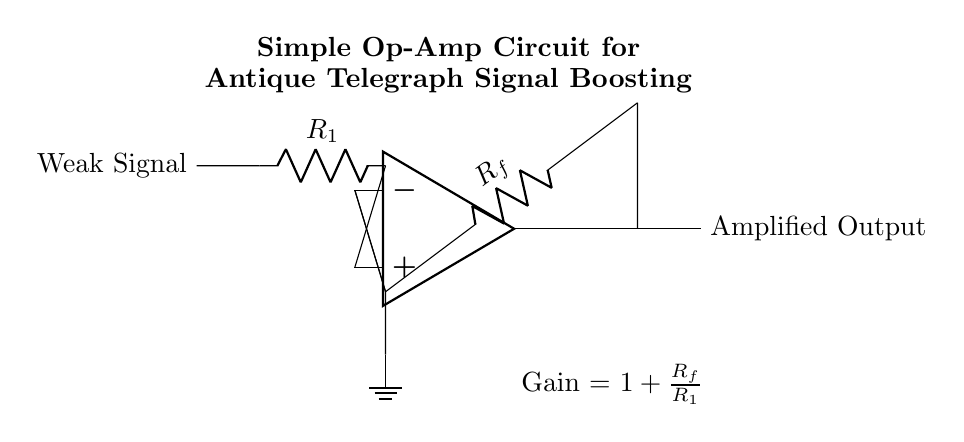What type of amplifier is shown in the circuit? The circuit represents an operational amplifier (op-amp) configuration designed for signal amplification. The label "op amp" in the circuit diagram indicates the specific component used for amplification.
Answer: operational amplifier What is the purpose of this circuit? The circuit's primary purpose is to boost weak signals, specifically for antique telegraph equipment. It's indicated in the label at the top of the diagram, showing it’s intended for signal boosting in telegraph applications.
Answer: boost weak signals What does Rf represent in the schematic? Rf, labeled in the diagram, represents the feedback resistor used in the op-amp configuration. Its placement in the feedback loop is essential for determining the gain of the amplifier.
Answer: feedback resistor How is the gain of the amplifier calculated? The gain of the amplifier is given by the formula "1 + Rf/R1." This is indicated in the circuit below the op-amp, showing how the feedback resistor and the input resistor R1 affect the overall gain.
Answer: 1 + Rf/R1 Which component is responsible for the input weak signal? The weak signal enters the circuit through the resistor R1, connected to the non-inverting input of the op-amp. The circuit shows that the signal is applied before R1 resistor.
Answer: R1 How does the circuit manage the output signal? The output signal is derived directly from the op-amp output terminal and is affected by the gain established by Rf and R1, indicating a clear path from the op-amp to the output. The diagram shows this connection clearly leading to the output terminal.
Answer: op-amp output What kind of load would typically be connected to the output? The circuit output is typically connected to an external load that requires a stronger amplified signal, such as a telegraph receiver or additional circuitry for further processing, although the exact load is not specified in the diagram.
Answer: telegraph receiver 